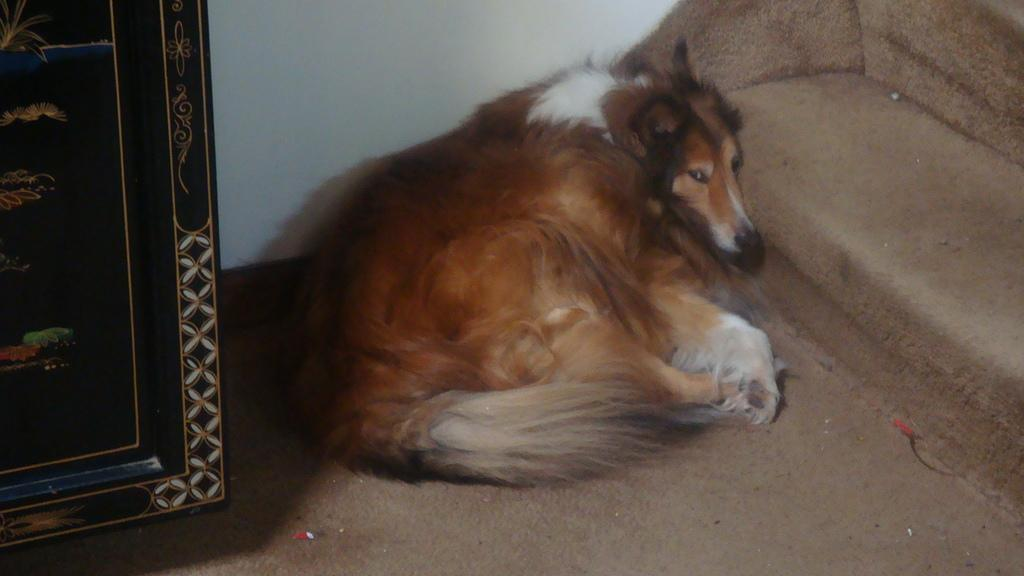What animal is sitting on the floor in the image? There is a dog sitting on the floor in the image. What type of object made of wood can be seen in the image? There is a wooden object in the image, which might be stairs. Are there any children playing with the dog in the image? There is no information about children in the image, so we cannot determine if they are present or playing with the dog. 